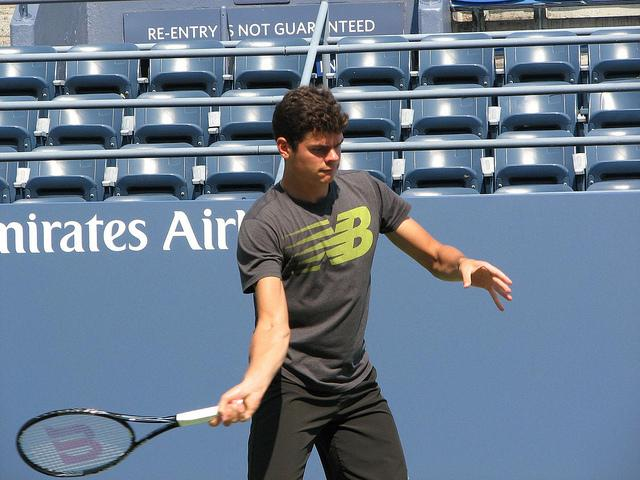What city is the sponsor of the arena located?

Choices:
A) dubai
B) denver
C) new york
D) calcutta dubai 